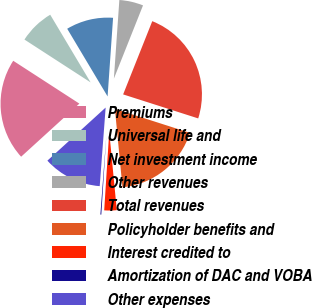Convert chart to OTSL. <chart><loc_0><loc_0><loc_500><loc_500><pie_chart><fcel>Premiums<fcel>Universal life and<fcel>Net investment income<fcel>Other revenues<fcel>Total revenues<fcel>Policyholder benefits and<fcel>Interest credited to<fcel>Amortization of DAC and VOBA<fcel>Other expenses<nl><fcel>20.91%<fcel>7.29%<fcel>9.67%<fcel>4.92%<fcel>23.9%<fcel>18.54%<fcel>2.55%<fcel>0.18%<fcel>12.04%<nl></chart> 